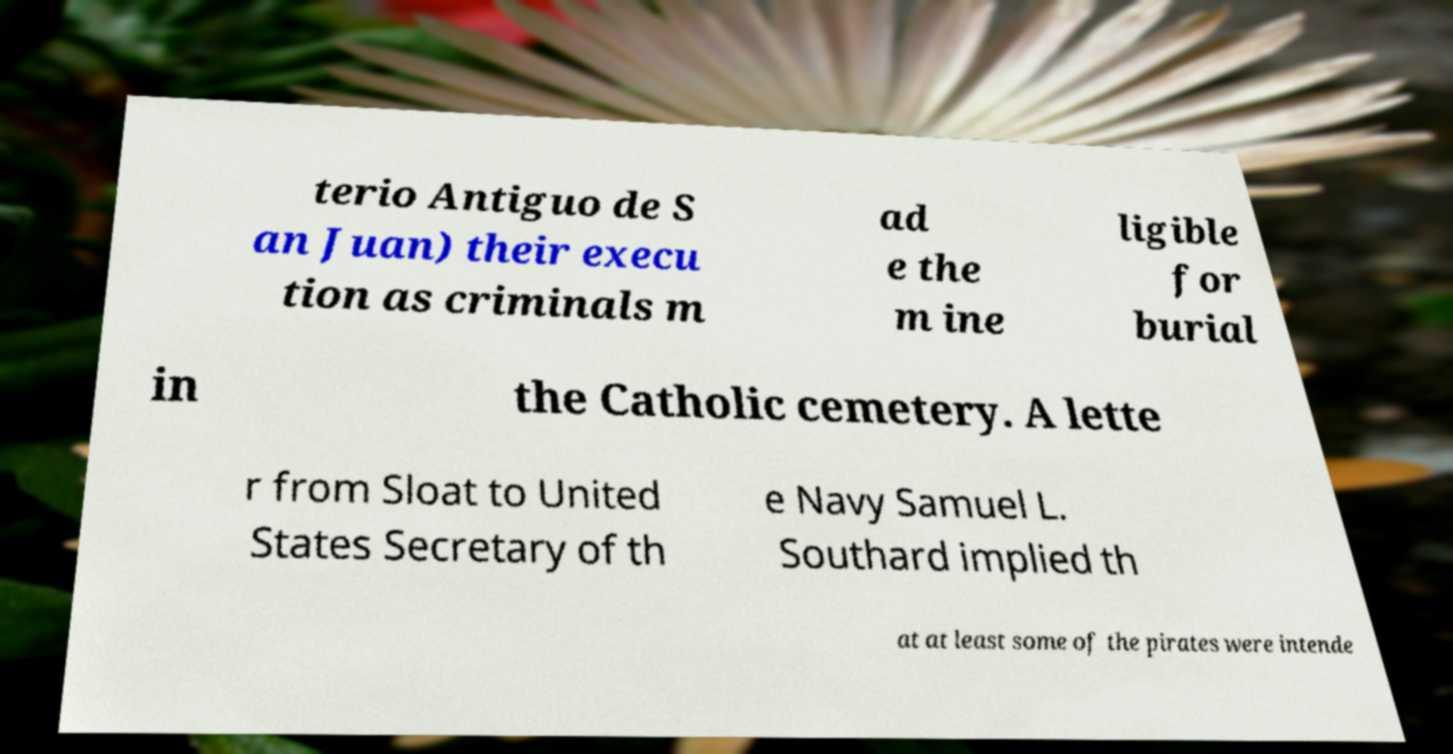There's text embedded in this image that I need extracted. Can you transcribe it verbatim? terio Antiguo de S an Juan) their execu tion as criminals m ad e the m ine ligible for burial in the Catholic cemetery. A lette r from Sloat to United States Secretary of th e Navy Samuel L. Southard implied th at at least some of the pirates were intende 